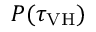Convert formula to latex. <formula><loc_0><loc_0><loc_500><loc_500>P ( \tau _ { V H } )</formula> 